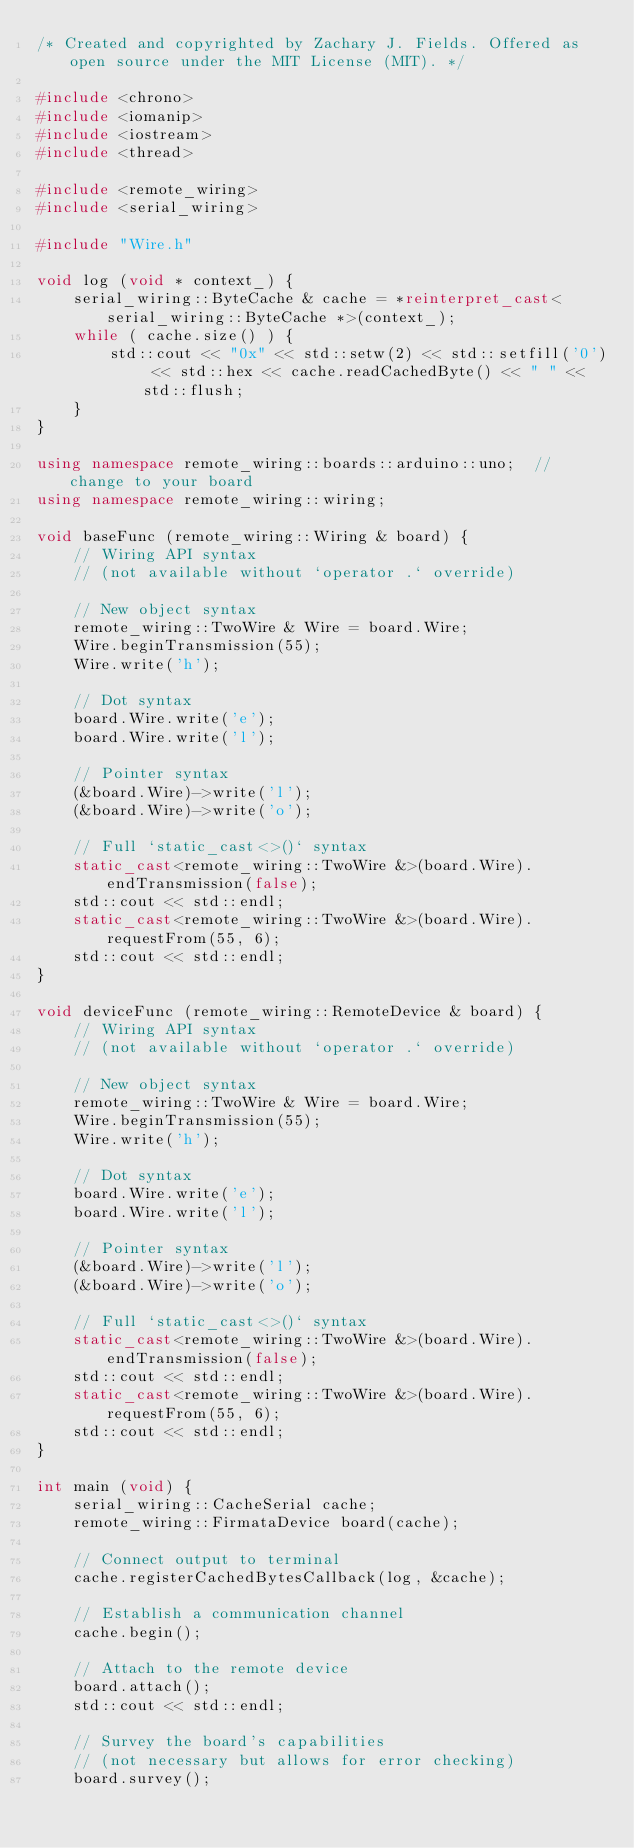Convert code to text. <code><loc_0><loc_0><loc_500><loc_500><_C++_>/* Created and copyrighted by Zachary J. Fields. Offered as open source under the MIT License (MIT). */

#include <chrono>
#include <iomanip>
#include <iostream>
#include <thread>

#include <remote_wiring>
#include <serial_wiring>

#include "Wire.h"

void log (void * context_) {
    serial_wiring::ByteCache & cache = *reinterpret_cast<serial_wiring::ByteCache *>(context_);
    while ( cache.size() ) {
        std::cout << "0x" << std::setw(2) << std::setfill('0') << std::hex << cache.readCachedByte() << " " << std::flush;
    }
}

using namespace remote_wiring::boards::arduino::uno;  // change to your board
using namespace remote_wiring::wiring;

void baseFunc (remote_wiring::Wiring & board) {
    // Wiring API syntax
    // (not available without `operator .` override)

    // New object syntax
    remote_wiring::TwoWire & Wire = board.Wire;
    Wire.beginTransmission(55);
    Wire.write('h');

    // Dot syntax
    board.Wire.write('e');
    board.Wire.write('l');
    
    // Pointer syntax
    (&board.Wire)->write('l');
    (&board.Wire)->write('o');

    // Full `static_cast<>()` syntax
    static_cast<remote_wiring::TwoWire &>(board.Wire).endTransmission(false);
    std::cout << std::endl;
    static_cast<remote_wiring::TwoWire &>(board.Wire).requestFrom(55, 6);
    std::cout << std::endl;
}

void deviceFunc (remote_wiring::RemoteDevice & board) {
    // Wiring API syntax
    // (not available without `operator .` override)

    // New object syntax
    remote_wiring::TwoWire & Wire = board.Wire;
    Wire.beginTransmission(55);
    Wire.write('h');

    // Dot syntax
    board.Wire.write('e');
    board.Wire.write('l');
    
    // Pointer syntax
    (&board.Wire)->write('l');
    (&board.Wire)->write('o');

    // Full `static_cast<>()` syntax
    static_cast<remote_wiring::TwoWire &>(board.Wire).endTransmission(false);
    std::cout << std::endl;
    static_cast<remote_wiring::TwoWire &>(board.Wire).requestFrom(55, 6);
    std::cout << std::endl;
}

int main (void) {
    serial_wiring::CacheSerial cache;
    remote_wiring::FirmataDevice board(cache);

    // Connect output to terminal
    cache.registerCachedBytesCallback(log, &cache);
    
    // Establish a communication channel
    cache.begin();

    // Attach to the remote device
    board.attach();
    std::cout << std::endl;
    
    // Survey the board's capabilities
    // (not necessary but allows for error checking)
    board.survey();</code> 